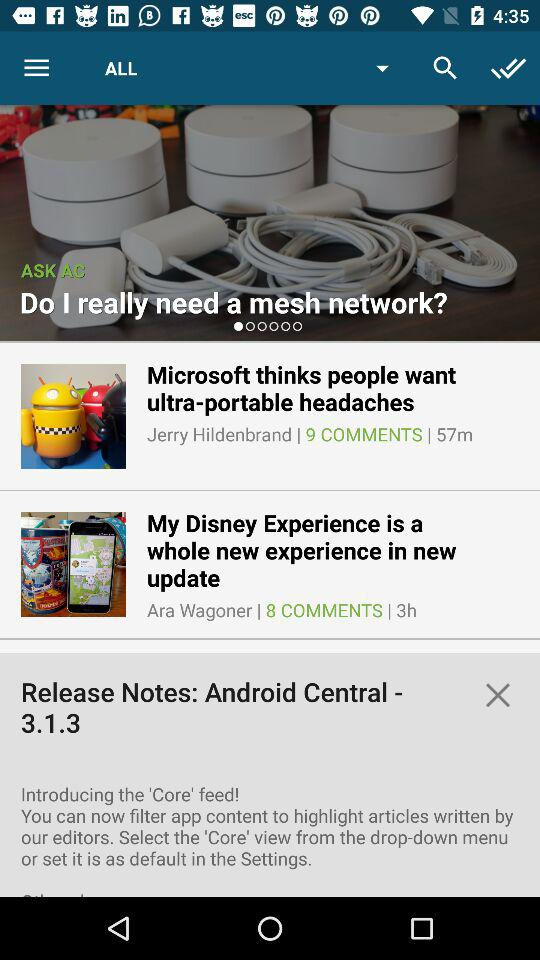How many minutes ago was "Microsoft thinks people want" posted? "Microsoft thinks people want" was posted 57 minutes ago. 